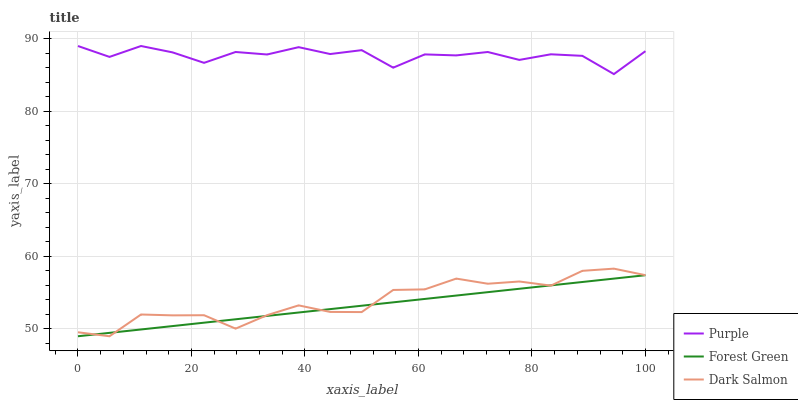Does Forest Green have the minimum area under the curve?
Answer yes or no. Yes. Does Purple have the maximum area under the curve?
Answer yes or no. Yes. Does Dark Salmon have the minimum area under the curve?
Answer yes or no. No. Does Dark Salmon have the maximum area under the curve?
Answer yes or no. No. Is Forest Green the smoothest?
Answer yes or no. Yes. Is Purple the roughest?
Answer yes or no. Yes. Is Dark Salmon the smoothest?
Answer yes or no. No. Is Dark Salmon the roughest?
Answer yes or no. No. Does Forest Green have the lowest value?
Answer yes or no. Yes. Does Purple have the highest value?
Answer yes or no. Yes. Does Dark Salmon have the highest value?
Answer yes or no. No. Is Forest Green less than Purple?
Answer yes or no. Yes. Is Purple greater than Dark Salmon?
Answer yes or no. Yes. Does Dark Salmon intersect Forest Green?
Answer yes or no. Yes. Is Dark Salmon less than Forest Green?
Answer yes or no. No. Is Dark Salmon greater than Forest Green?
Answer yes or no. No. Does Forest Green intersect Purple?
Answer yes or no. No. 